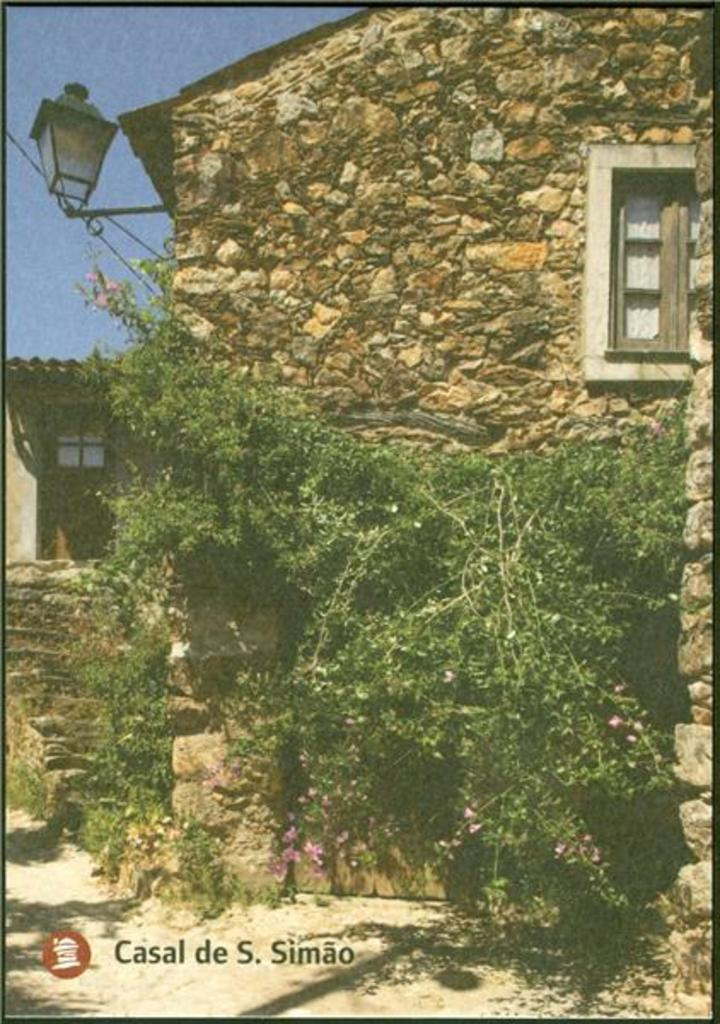What is located in the middle of the image? There are plants in the middle of the image. What type of structure can be seen in the image? There appears to be a house in the image. What object is on the left side of the image? There is a lamp on the left side of the image. What is visible at the top of the image? The sky is visible at the top of the image. What is written or depicted at the bottom of the image? There is text at the bottom of the image. How many pets are visible in the image? There are no pets present in the image. What type of grip does the lamp have in the image? The image does not provide information about the grip of the lamp. 